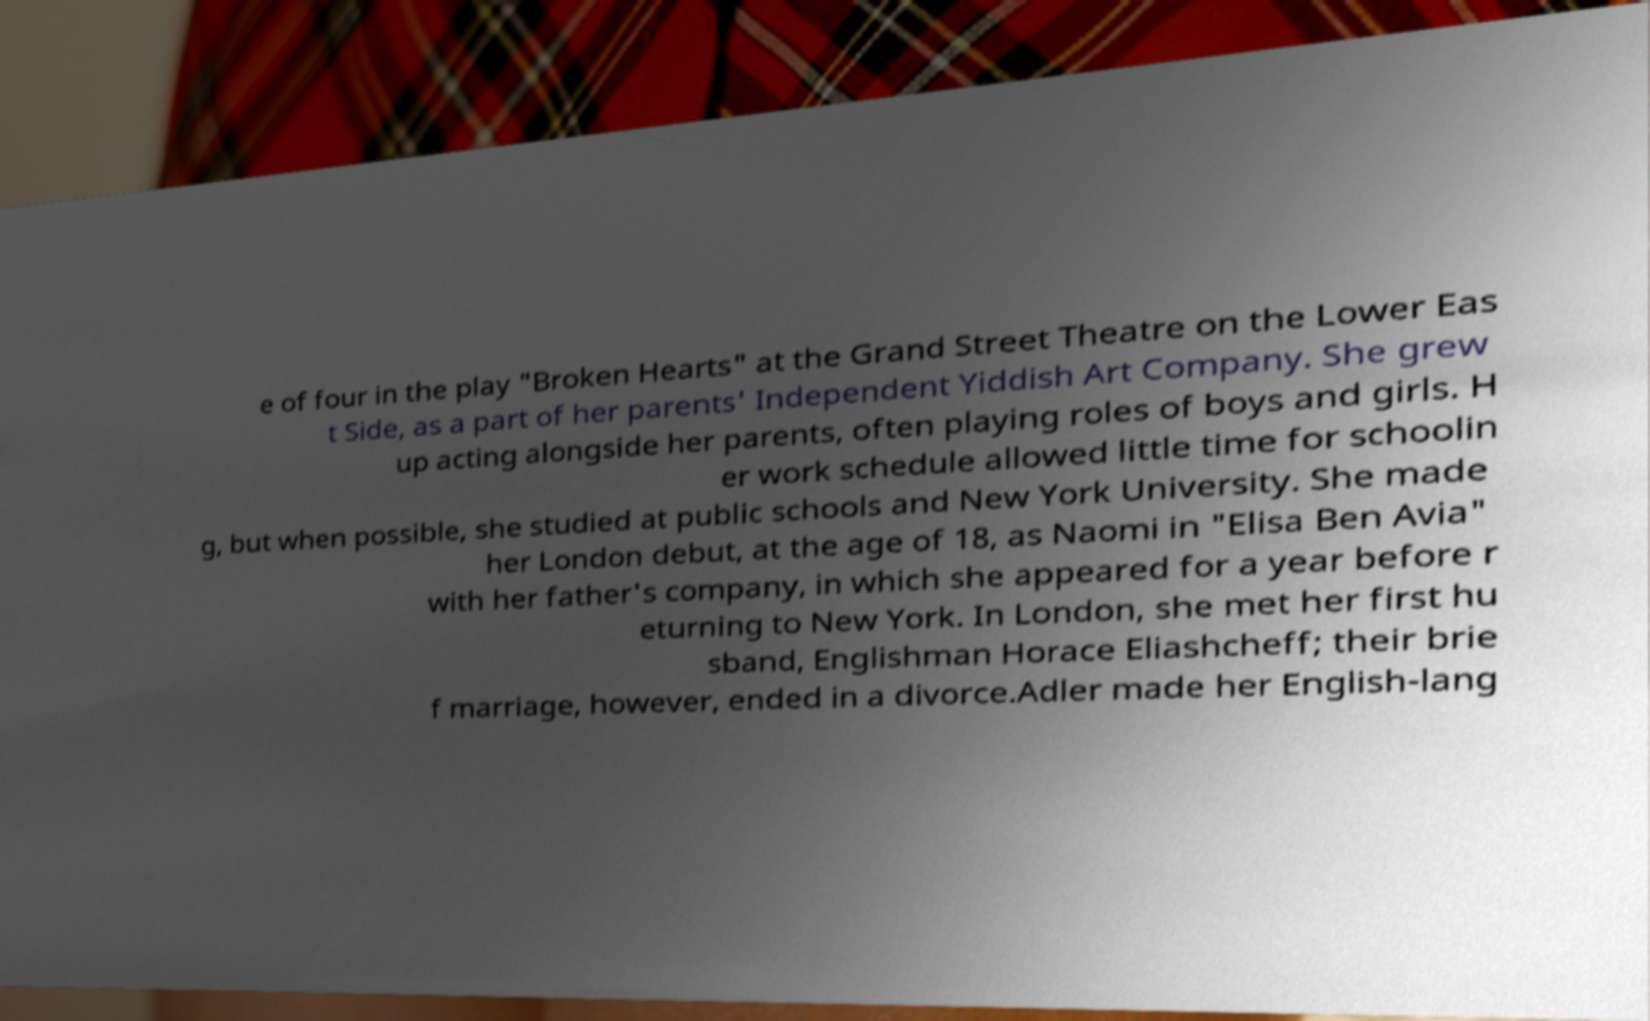Can you read and provide the text displayed in the image?This photo seems to have some interesting text. Can you extract and type it out for me? e of four in the play "Broken Hearts" at the Grand Street Theatre on the Lower Eas t Side, as a part of her parents' Independent Yiddish Art Company. She grew up acting alongside her parents, often playing roles of boys and girls. H er work schedule allowed little time for schoolin g, but when possible, she studied at public schools and New York University. She made her London debut, at the age of 18, as Naomi in "Elisa Ben Avia" with her father's company, in which she appeared for a year before r eturning to New York. In London, she met her first hu sband, Englishman Horace Eliashcheff; their brie f marriage, however, ended in a divorce.Adler made her English-lang 